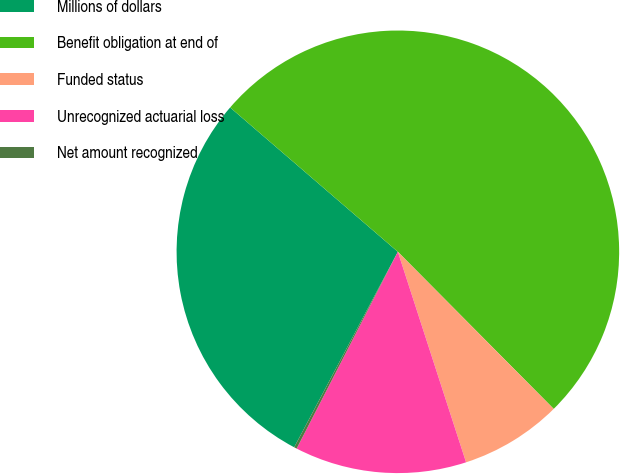Convert chart to OTSL. <chart><loc_0><loc_0><loc_500><loc_500><pie_chart><fcel>Millions of dollars<fcel>Benefit obligation at end of<fcel>Funded status<fcel>Unrecognized actuarial loss<fcel>Net amount recognized<nl><fcel>28.55%<fcel>51.26%<fcel>7.45%<fcel>12.55%<fcel>0.2%<nl></chart> 